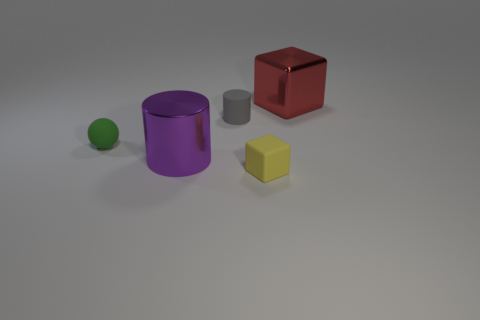What is the shape of the big purple shiny object?
Ensure brevity in your answer.  Cylinder. How many large green things have the same material as the small yellow object?
Give a very brief answer. 0. How many large purple cylinders are there?
Keep it short and to the point. 1. What color is the thing that is in front of the large metal thing in front of the cylinder that is to the right of the purple metallic cylinder?
Offer a very short reply. Yellow. Are the tiny yellow object and the object right of the yellow rubber block made of the same material?
Your response must be concise. No. What material is the yellow thing?
Provide a short and direct response. Rubber. How many other things are there of the same material as the green ball?
Keep it short and to the point. 2. The tiny thing that is both in front of the small matte cylinder and on the right side of the big purple thing has what shape?
Ensure brevity in your answer.  Cube. What color is the tiny ball that is made of the same material as the tiny gray cylinder?
Your answer should be very brief. Green. Is the number of yellow objects to the left of the sphere the same as the number of red shiny cubes?
Provide a short and direct response. No. 